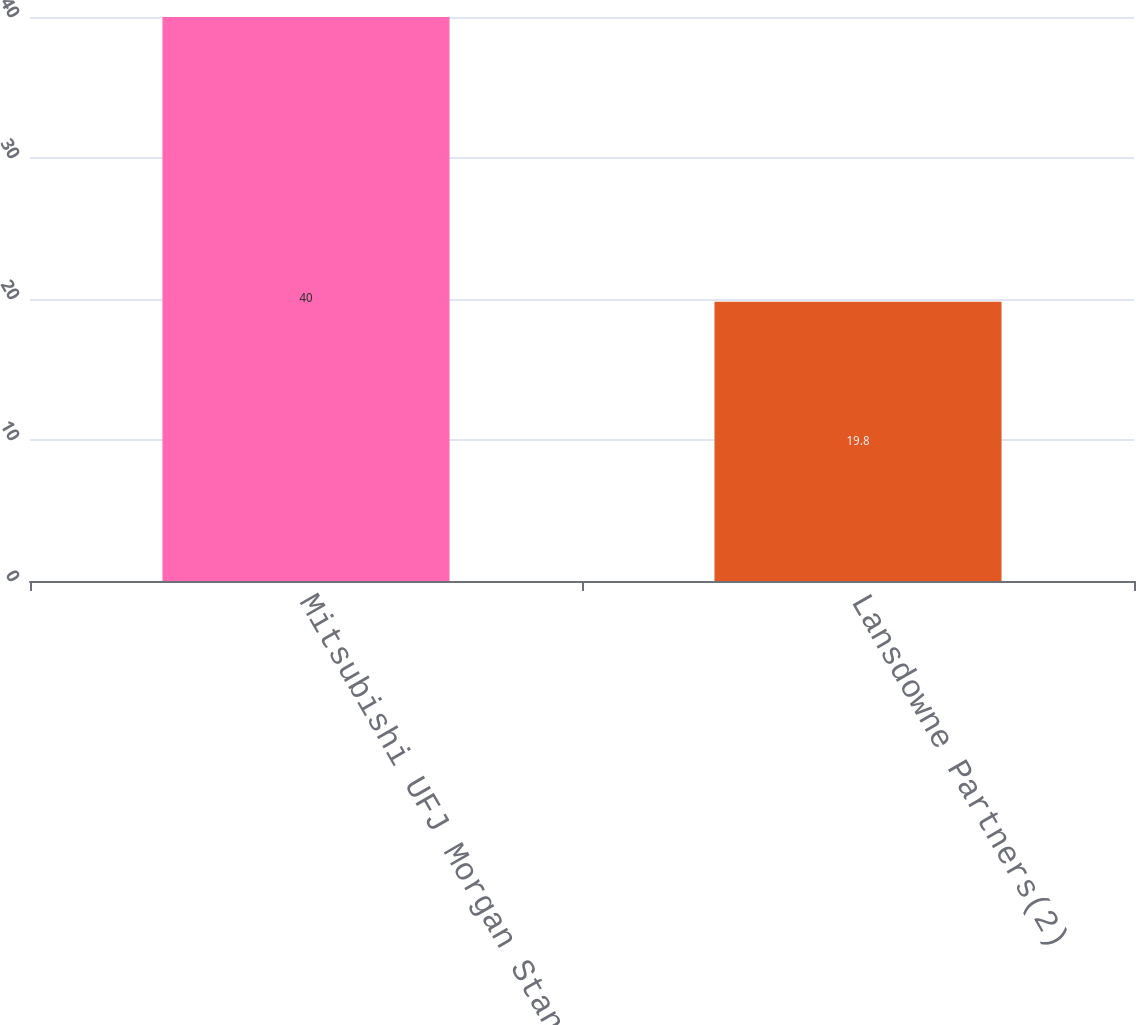<chart> <loc_0><loc_0><loc_500><loc_500><bar_chart><fcel>Mitsubishi UFJ Morgan Stanley<fcel>Lansdowne Partners(2)<nl><fcel>40<fcel>19.8<nl></chart> 